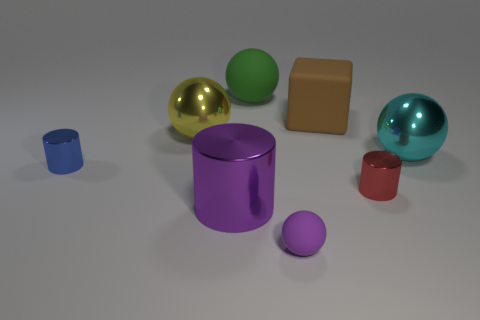Subtract all small metal cylinders. How many cylinders are left? 1 Subtract all green balls. How many balls are left? 3 Subtract all cylinders. How many objects are left? 5 Subtract 3 balls. How many balls are left? 1 Add 5 big matte spheres. How many big matte spheres are left? 6 Add 1 purple spheres. How many purple spheres exist? 2 Add 2 brown shiny spheres. How many objects exist? 10 Subtract 1 red cylinders. How many objects are left? 7 Subtract all yellow balls. Subtract all brown blocks. How many balls are left? 3 Subtract all brown cubes. How many cyan cylinders are left? 0 